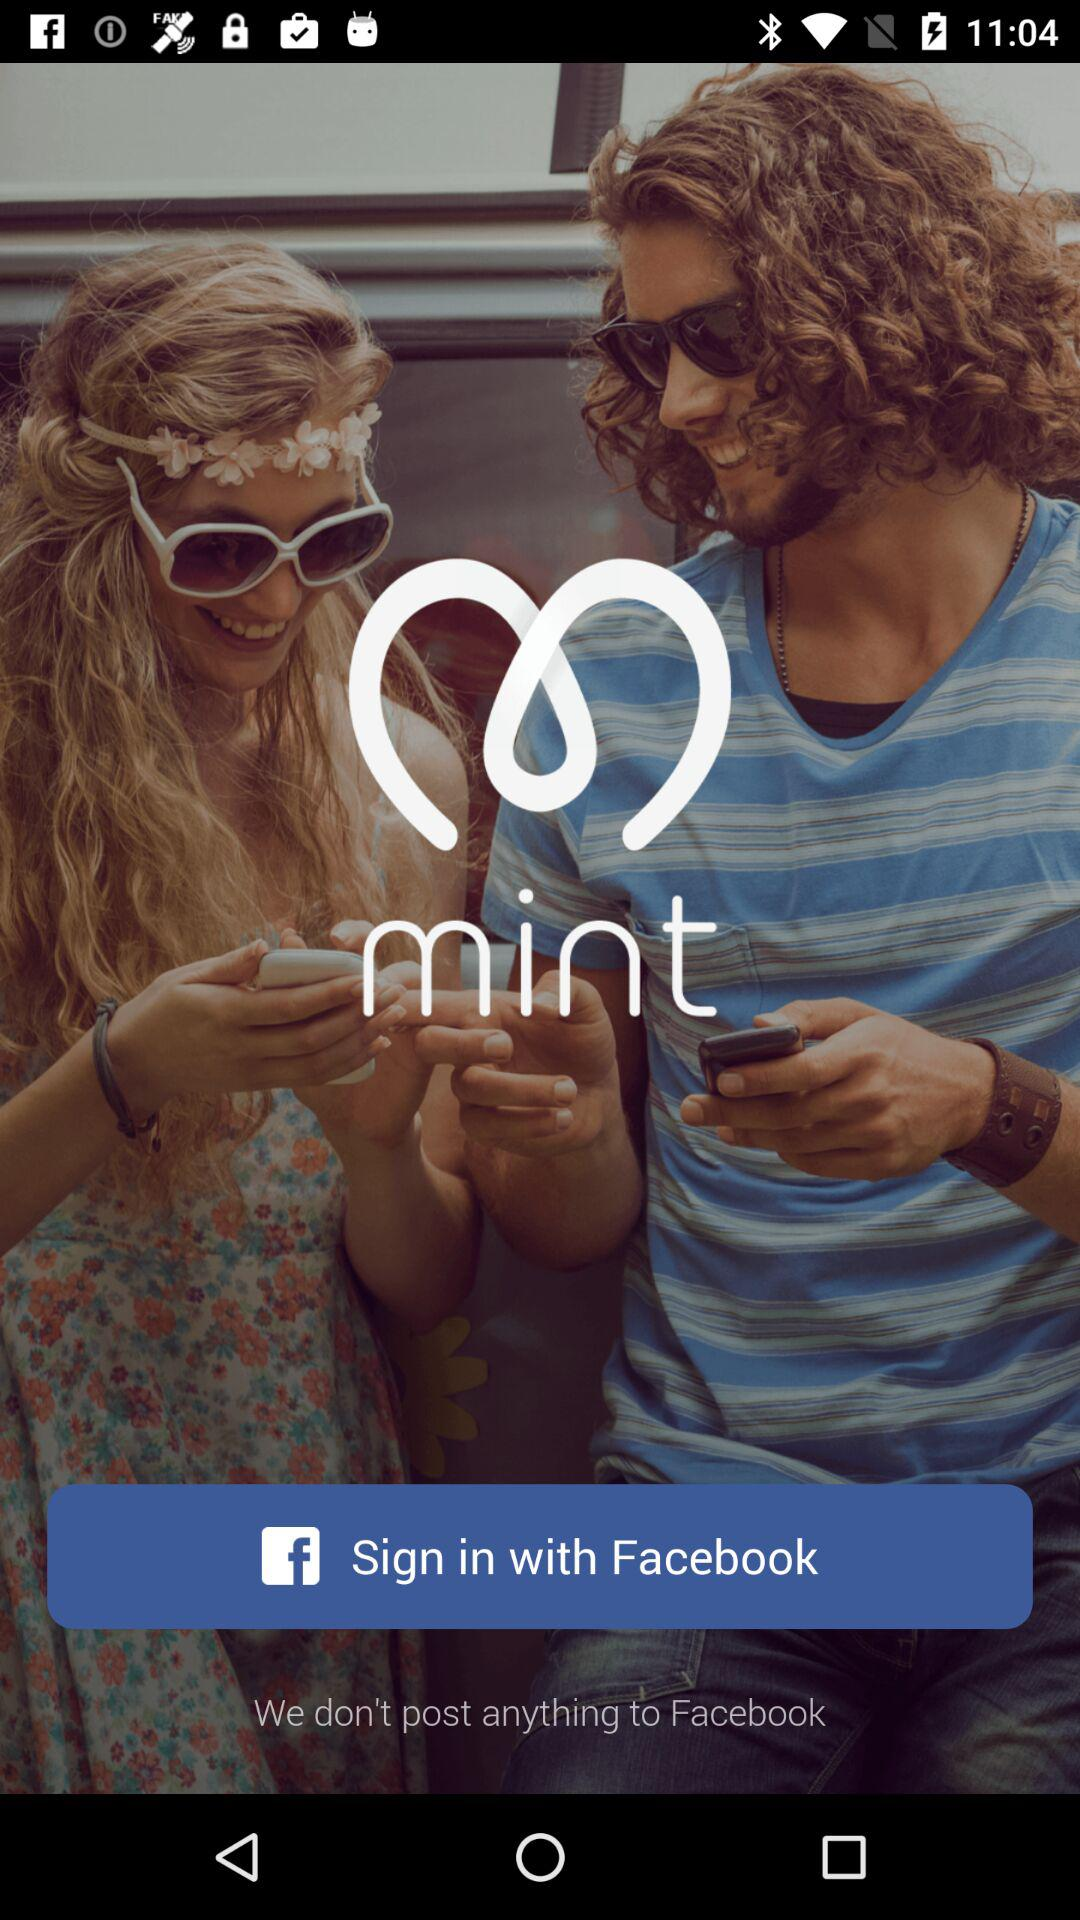What is the application name? The application name is "mint". 